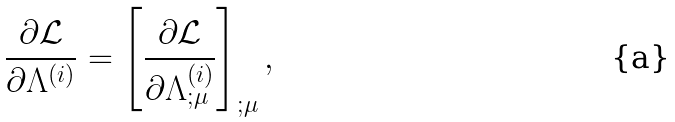Convert formula to latex. <formula><loc_0><loc_0><loc_500><loc_500>\frac { \partial \mathcal { L } } { \partial \Lambda ^ { ( i ) } } = \left [ \frac { \partial \mathcal { L } } { \partial \Lambda _ { ; \mu } ^ { ( i ) } } \right ] _ { ; \mu } ,</formula> 